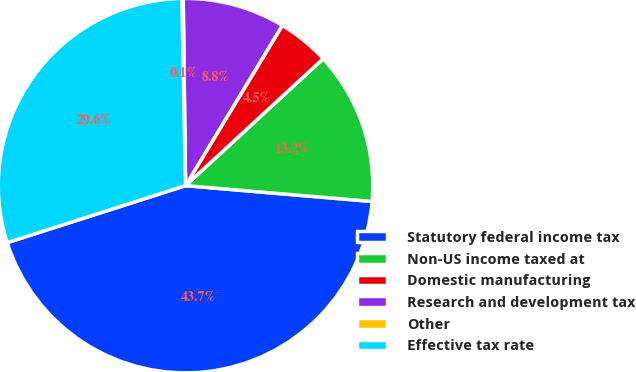<chart> <loc_0><loc_0><loc_500><loc_500><pie_chart><fcel>Statutory federal income tax<fcel>Non-US income taxed at<fcel>Domestic manufacturing<fcel>Research and development tax<fcel>Other<fcel>Effective tax rate<nl><fcel>43.73%<fcel>13.21%<fcel>4.49%<fcel>8.85%<fcel>0.12%<fcel>29.61%<nl></chart> 